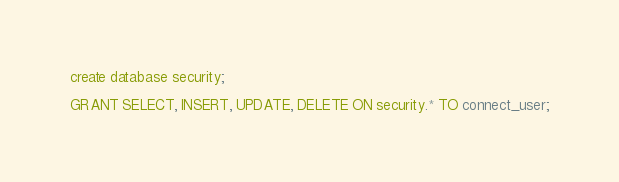<code> <loc_0><loc_0><loc_500><loc_500><_SQL_>create database security;

GRANT SELECT, INSERT, UPDATE, DELETE ON security.* TO connect_user;
</code> 